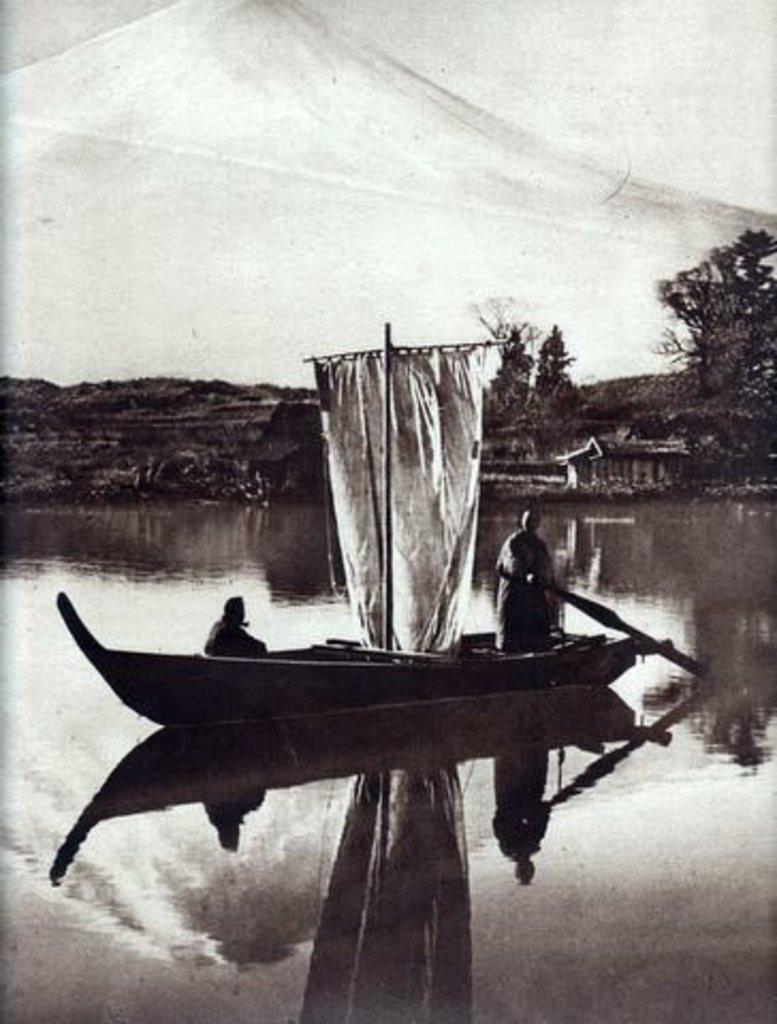How would you summarize this image in a sentence or two? This is black and white image where we can see two people are in boat and the boat is on the surface of water. We can see trees in the background and one mountain. 